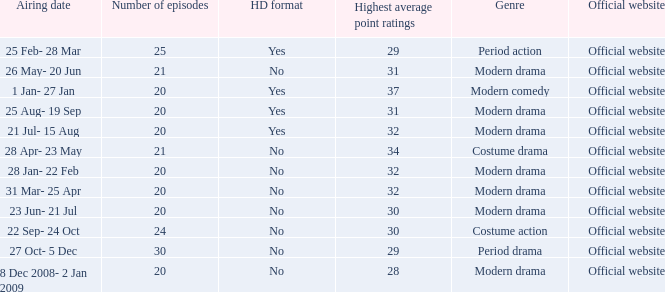What are the number of episodes when the genre is modern drama and the highest average ratings points are 28? 20.0. 